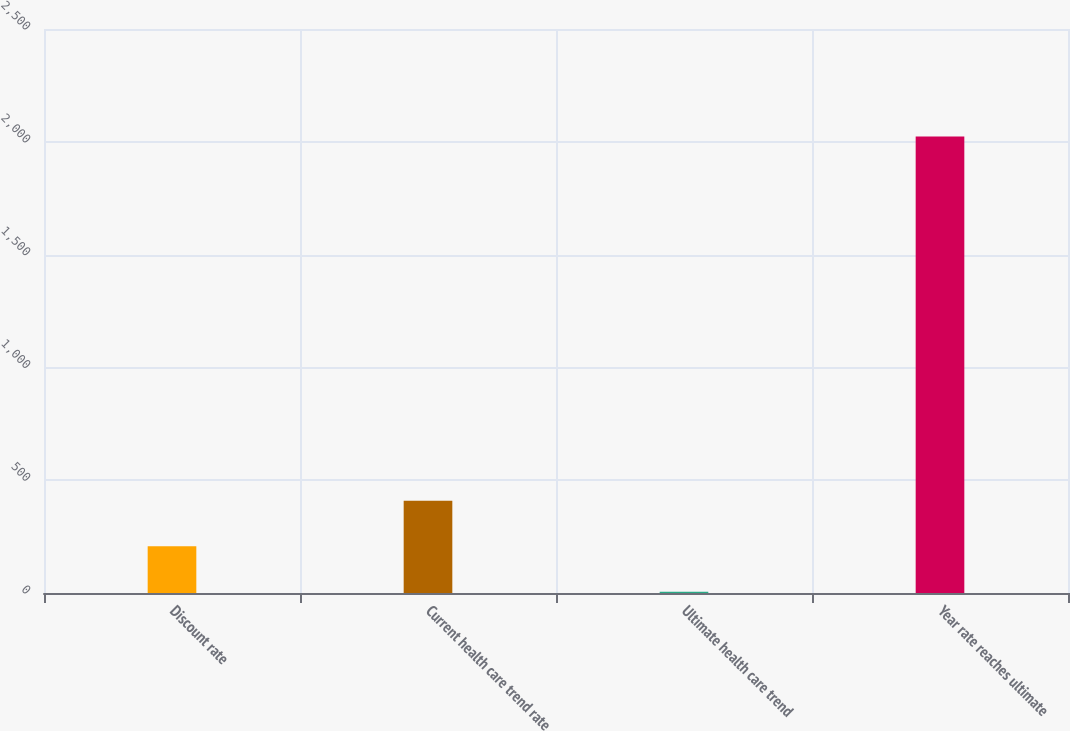<chart> <loc_0><loc_0><loc_500><loc_500><bar_chart><fcel>Discount rate<fcel>Current health care trend rate<fcel>Ultimate health care trend<fcel>Year rate reaches ultimate<nl><fcel>206.8<fcel>408.6<fcel>5<fcel>2023<nl></chart> 